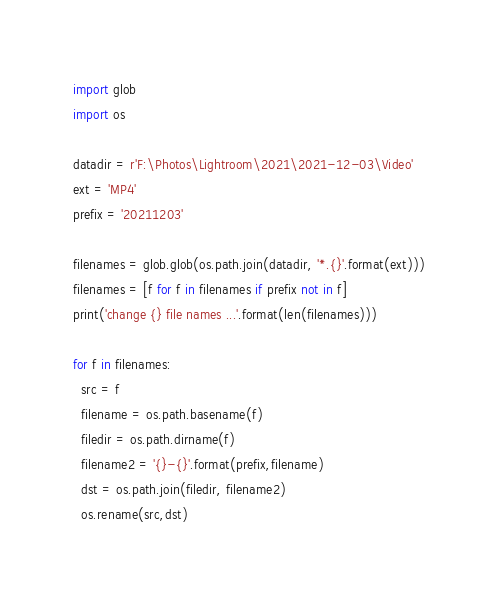<code> <loc_0><loc_0><loc_500><loc_500><_Python_>
import glob
import os

datadir = r'F:\Photos\Lightroom\2021\2021-12-03\Video'
ext = 'MP4'
prefix = '20211203'

filenames = glob.glob(os.path.join(datadir, '*.{}'.format(ext)))
filenames = [f for f in filenames if prefix not in f]
print('change {} file names ...'.format(len(filenames)))

for f in filenames:
  src = f
  filename = os.path.basename(f)
  filedir = os.path.dirname(f)
  filename2 = '{}-{}'.format(prefix,filename)
  dst = os.path.join(filedir, filename2)
  os.rename(src,dst)
</code> 